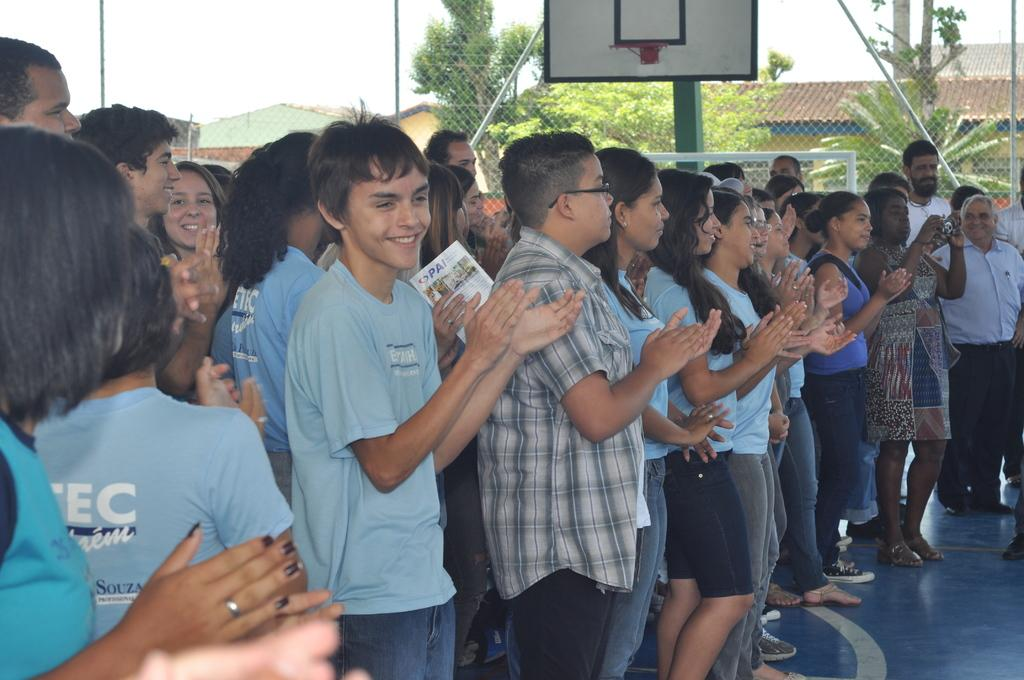What are the people in the image doing? Some people are clapping their hands in the image. Can you describe the surroundings of the people? There is a fence in the image, and trees and buildings can be seen in the background. How many tomatoes can be seen on the ladybug's back in the image? There are no tomatoes or ladybugs present in the image. What is the ladybug doing with its finger in the image? There is no ladybug or finger present in the image. 